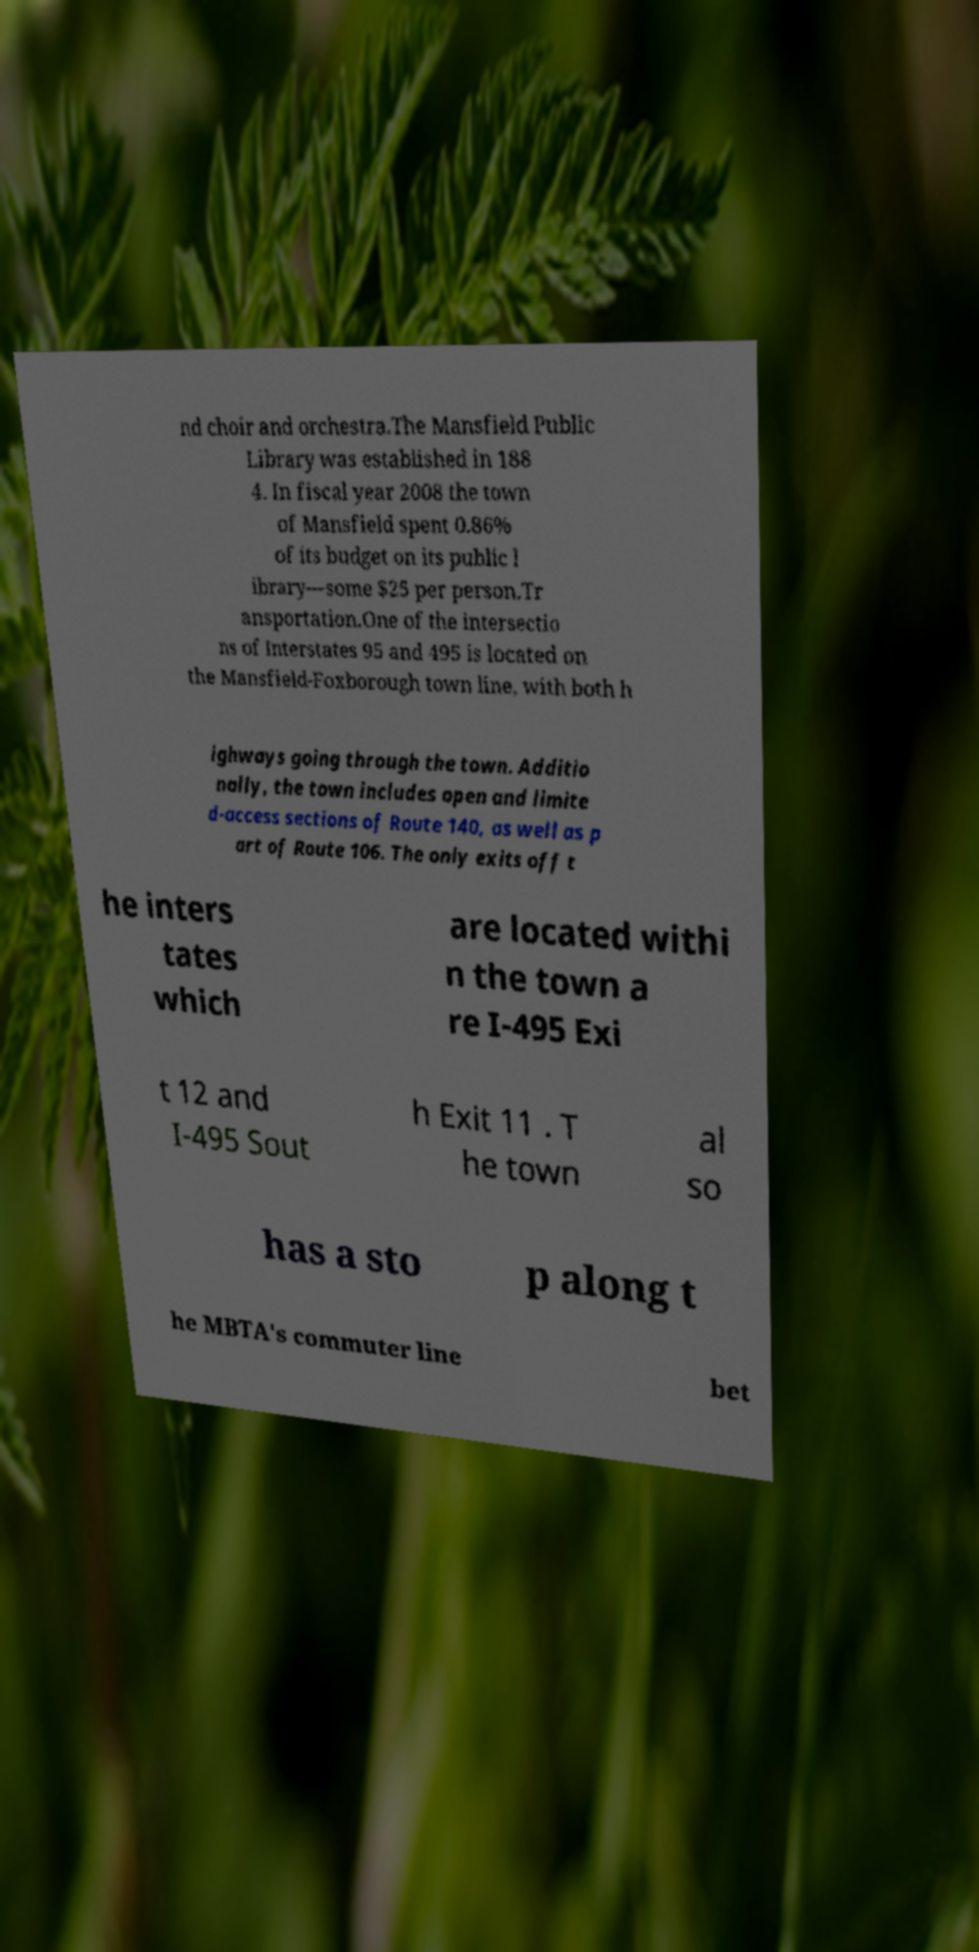Could you assist in decoding the text presented in this image and type it out clearly? nd choir and orchestra.The Mansfield Public Library was established in 188 4. In fiscal year 2008 the town of Mansfield spent 0.86% of its budget on its public l ibrary—some $25 per person.Tr ansportation.One of the intersectio ns of Interstates 95 and 495 is located on the Mansfield-Foxborough town line, with both h ighways going through the town. Additio nally, the town includes open and limite d-access sections of Route 140, as well as p art of Route 106. The only exits off t he inters tates which are located withi n the town a re I-495 Exi t 12 and I-495 Sout h Exit 11 . T he town al so has a sto p along t he MBTA's commuter line bet 